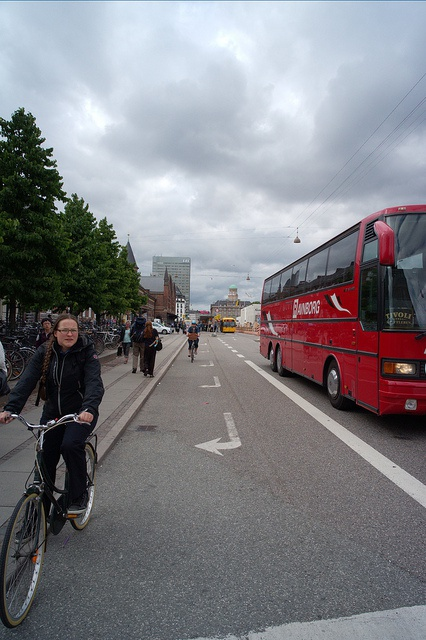Describe the objects in this image and their specific colors. I can see bus in lightblue, black, maroon, and gray tones, people in lightblue, black, gray, and maroon tones, bicycle in lightblue, black, gray, olive, and darkgray tones, people in lightblue, black, gray, darkgray, and maroon tones, and people in lightblue, black, and gray tones in this image. 